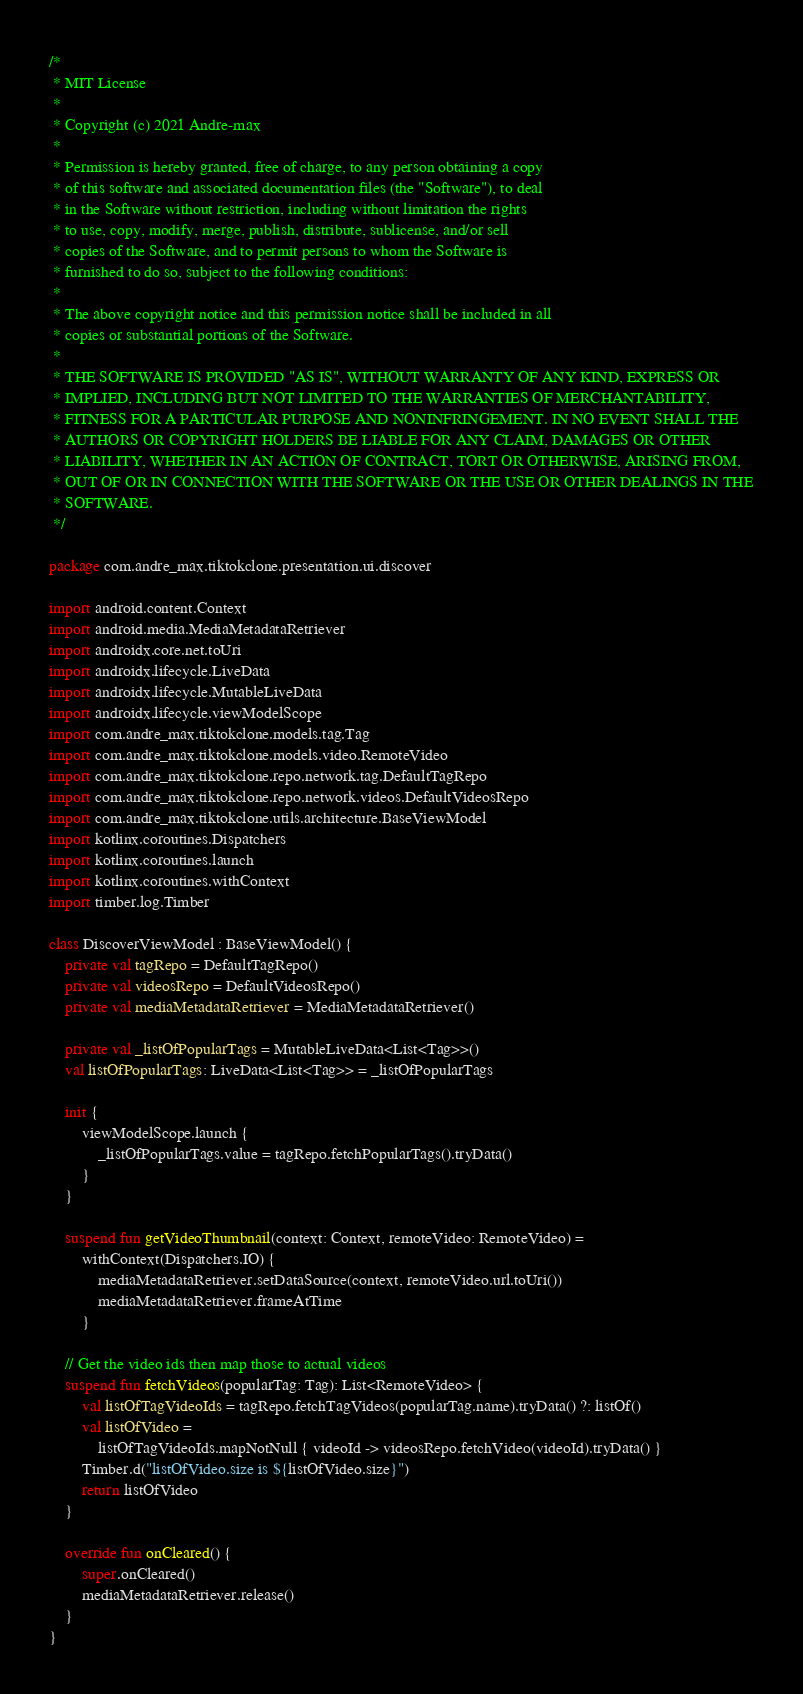<code> <loc_0><loc_0><loc_500><loc_500><_Kotlin_>/*
 * MIT License
 *
 * Copyright (c) 2021 Andre-max
 *
 * Permission is hereby granted, free of charge, to any person obtaining a copy
 * of this software and associated documentation files (the "Software"), to deal
 * in the Software without restriction, including without limitation the rights
 * to use, copy, modify, merge, publish, distribute, sublicense, and/or sell
 * copies of the Software, and to permit persons to whom the Software is
 * furnished to do so, subject to the following conditions:
 *
 * The above copyright notice and this permission notice shall be included in all
 * copies or substantial portions of the Software.
 *
 * THE SOFTWARE IS PROVIDED "AS IS", WITHOUT WARRANTY OF ANY KIND, EXPRESS OR
 * IMPLIED, INCLUDING BUT NOT LIMITED TO THE WARRANTIES OF MERCHANTABILITY,
 * FITNESS FOR A PARTICULAR PURPOSE AND NONINFRINGEMENT. IN NO EVENT SHALL THE
 * AUTHORS OR COPYRIGHT HOLDERS BE LIABLE FOR ANY CLAIM, DAMAGES OR OTHER
 * LIABILITY, WHETHER IN AN ACTION OF CONTRACT, TORT OR OTHERWISE, ARISING FROM,
 * OUT OF OR IN CONNECTION WITH THE SOFTWARE OR THE USE OR OTHER DEALINGS IN THE
 * SOFTWARE.
 */

package com.andre_max.tiktokclone.presentation.ui.discover

import android.content.Context
import android.media.MediaMetadataRetriever
import androidx.core.net.toUri
import androidx.lifecycle.LiveData
import androidx.lifecycle.MutableLiveData
import androidx.lifecycle.viewModelScope
import com.andre_max.tiktokclone.models.tag.Tag
import com.andre_max.tiktokclone.models.video.RemoteVideo
import com.andre_max.tiktokclone.repo.network.tag.DefaultTagRepo
import com.andre_max.tiktokclone.repo.network.videos.DefaultVideosRepo
import com.andre_max.tiktokclone.utils.architecture.BaseViewModel
import kotlinx.coroutines.Dispatchers
import kotlinx.coroutines.launch
import kotlinx.coroutines.withContext
import timber.log.Timber

class DiscoverViewModel : BaseViewModel() {
    private val tagRepo = DefaultTagRepo()
    private val videosRepo = DefaultVideosRepo()
    private val mediaMetadataRetriever = MediaMetadataRetriever()

    private val _listOfPopularTags = MutableLiveData<List<Tag>>()
    val listOfPopularTags: LiveData<List<Tag>> = _listOfPopularTags

    init {
        viewModelScope.launch {
            _listOfPopularTags.value = tagRepo.fetchPopularTags().tryData()
        }
    }

    suspend fun getVideoThumbnail(context: Context, remoteVideo: RemoteVideo) =
        withContext(Dispatchers.IO) {
            mediaMetadataRetriever.setDataSource(context, remoteVideo.url.toUri())
            mediaMetadataRetriever.frameAtTime
        }

    // Get the video ids then map those to actual videos
    suspend fun fetchVideos(popularTag: Tag): List<RemoteVideo> {
        val listOfTagVideoIds = tagRepo.fetchTagVideos(popularTag.name).tryData() ?: listOf()
        val listOfVideo =
            listOfTagVideoIds.mapNotNull { videoId -> videosRepo.fetchVideo(videoId).tryData() }
        Timber.d("listOfVideo.size is ${listOfVideo.size}")
        return listOfVideo
    }

    override fun onCleared() {
        super.onCleared()
        mediaMetadataRetriever.release()
    }
}</code> 